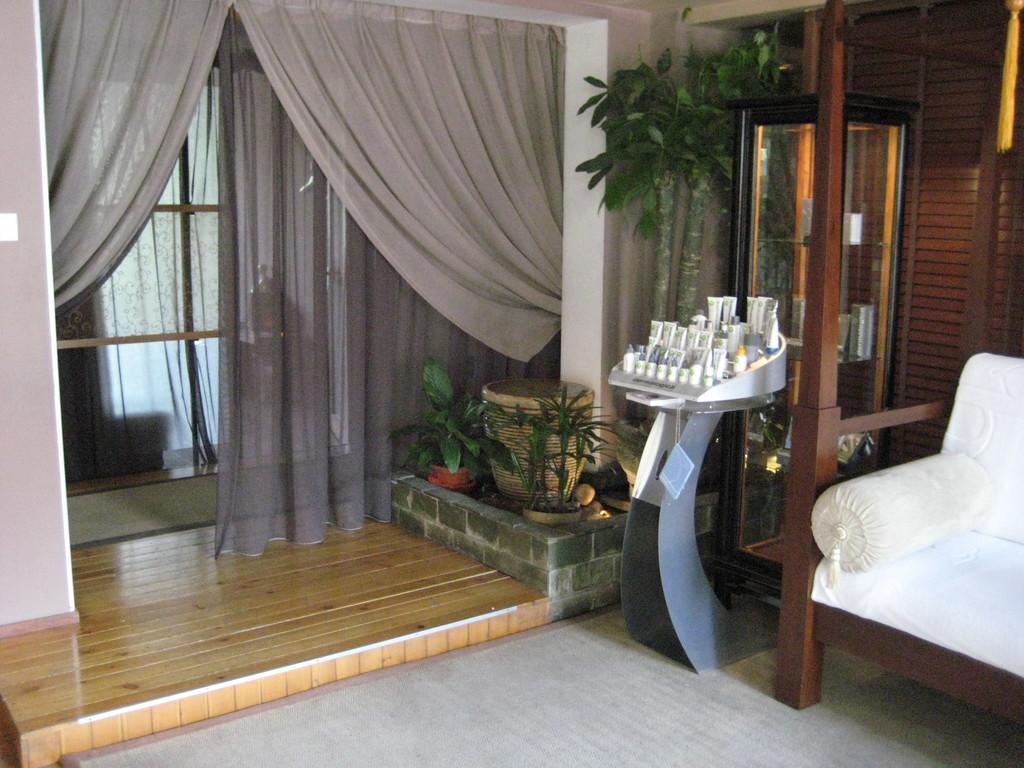Please provide a concise description of this image. On the right side, there is a pillow on a sofa. Beside this sofa, there are bottles arranged in an object. This object is on a stand, there is a glass box. Beside this glass box, there are plants. On the left side, there are curtains. In the background, there is another curtain. 